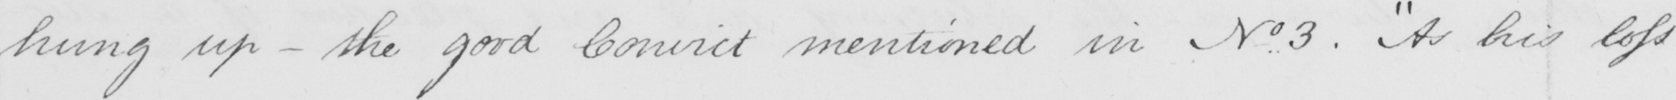Transcribe the text shown in this historical manuscript line. hung up  _  the good Convict mentioned in No..3 .  " As his loss 